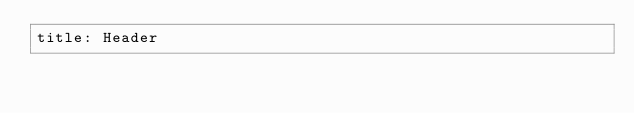<code> <loc_0><loc_0><loc_500><loc_500><_YAML_>title: Header
</code> 